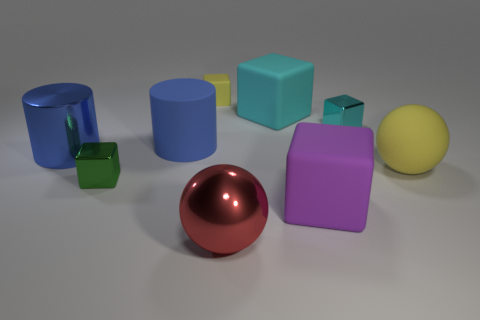Subtract all purple blocks. How many blocks are left? 4 Subtract all purple cubes. How many cubes are left? 4 Add 1 tiny objects. How many objects exist? 10 Subtract all gray spheres. Subtract all red blocks. How many spheres are left? 2 Subtract all blocks. How many objects are left? 4 Add 9 large green shiny objects. How many large green shiny objects exist? 9 Subtract 1 green cubes. How many objects are left? 8 Subtract all large cyan cubes. Subtract all blue things. How many objects are left? 6 Add 3 big blue metallic things. How many big blue metallic things are left? 4 